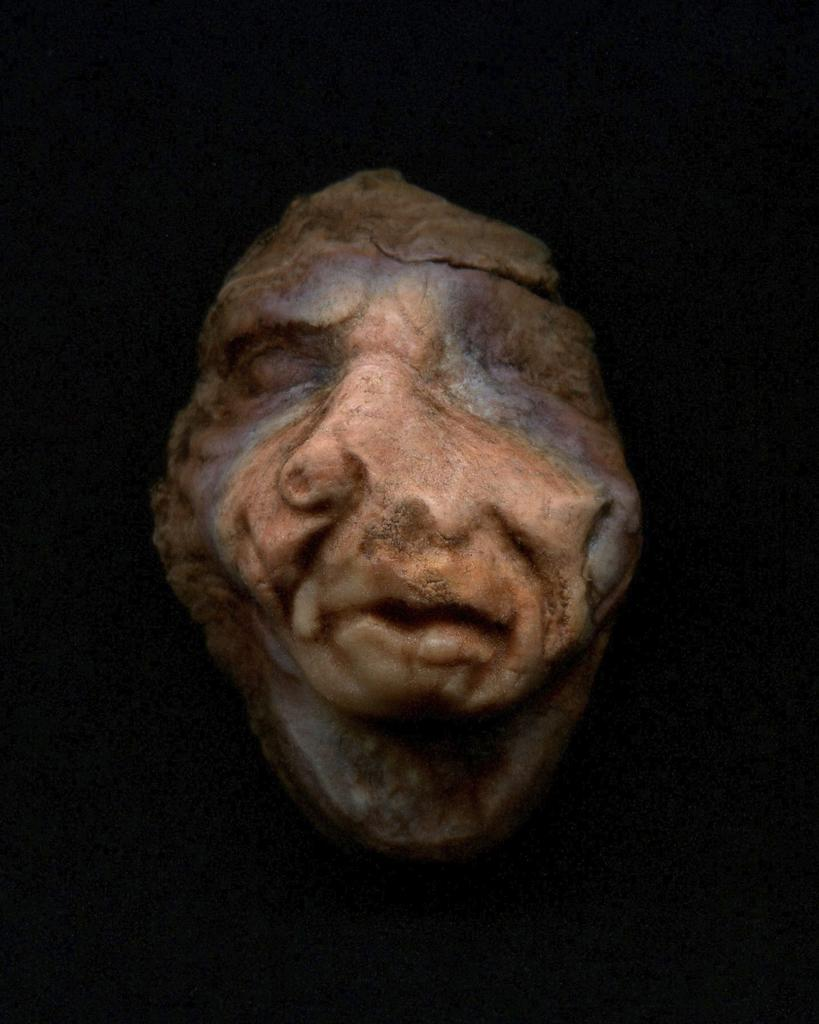What is the main subject of the image? The main subject of the image is a rock. What is unique about the rock in the image? The rock is carved in the shape of a person's face. What color is the background of the image? The background of the image is black. What type of activity is the creator of the rock carving engaged in during the image? There is no indication of the creator's presence or activity in the image, as it only shows the rock carving and the black background. 